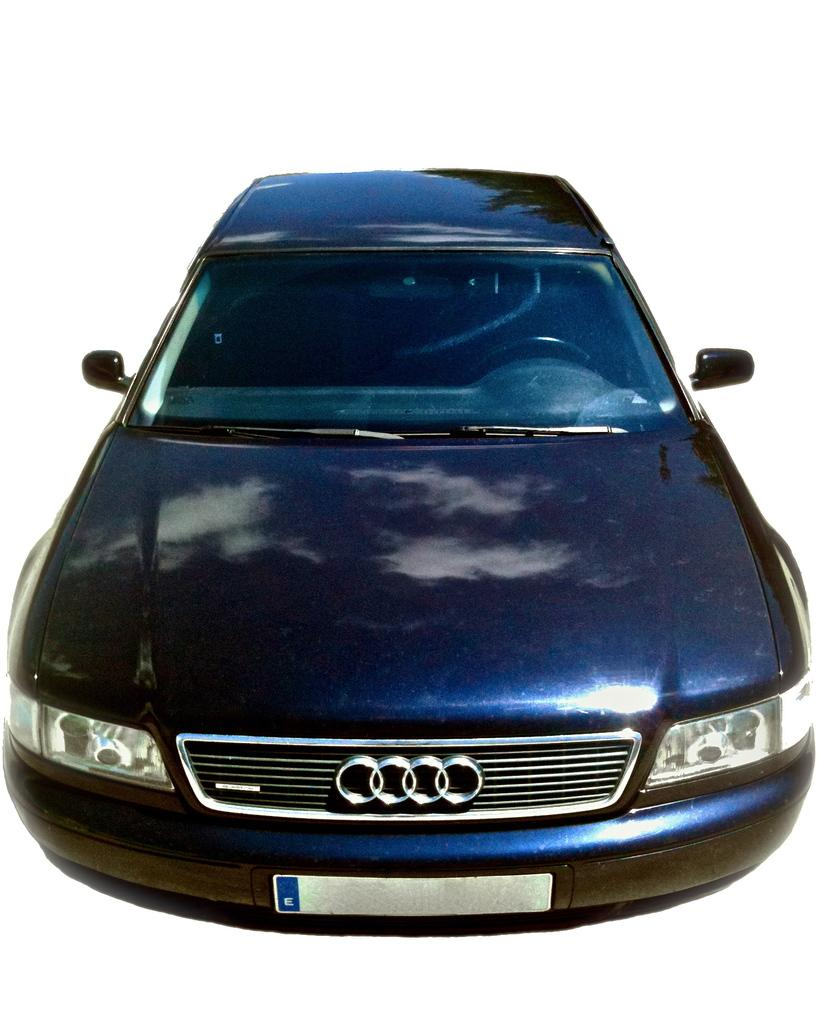What is the main subject of the image? The main subject of the image is a car. What feature of the car is mentioned in the facts? The car has a vehicle registration plate. What is the color of the background in the image? The background of the image is white in color. What type of mouth is visible on the car in the image? There is no mouth present on the car in the image. What offer is being made by the car in the image? The car is not making any offer in the image; it is a stationary object. 